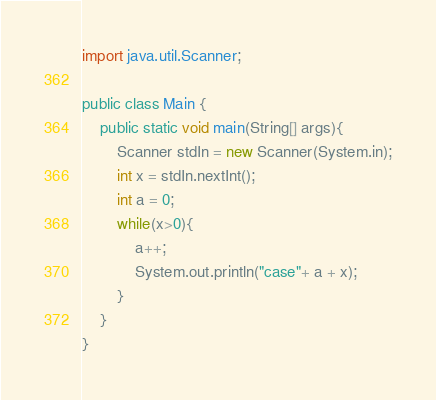Convert code to text. <code><loc_0><loc_0><loc_500><loc_500><_Java_>import java.util.Scanner;

public class Main {
	public static void main(String[] args){
		Scanner stdIn = new Scanner(System.in);
		int x = stdIn.nextInt();
		int a = 0;
		while(x>0){
			a++;
			System.out.println("case"+ a + x);
		}
	}
}

</code> 